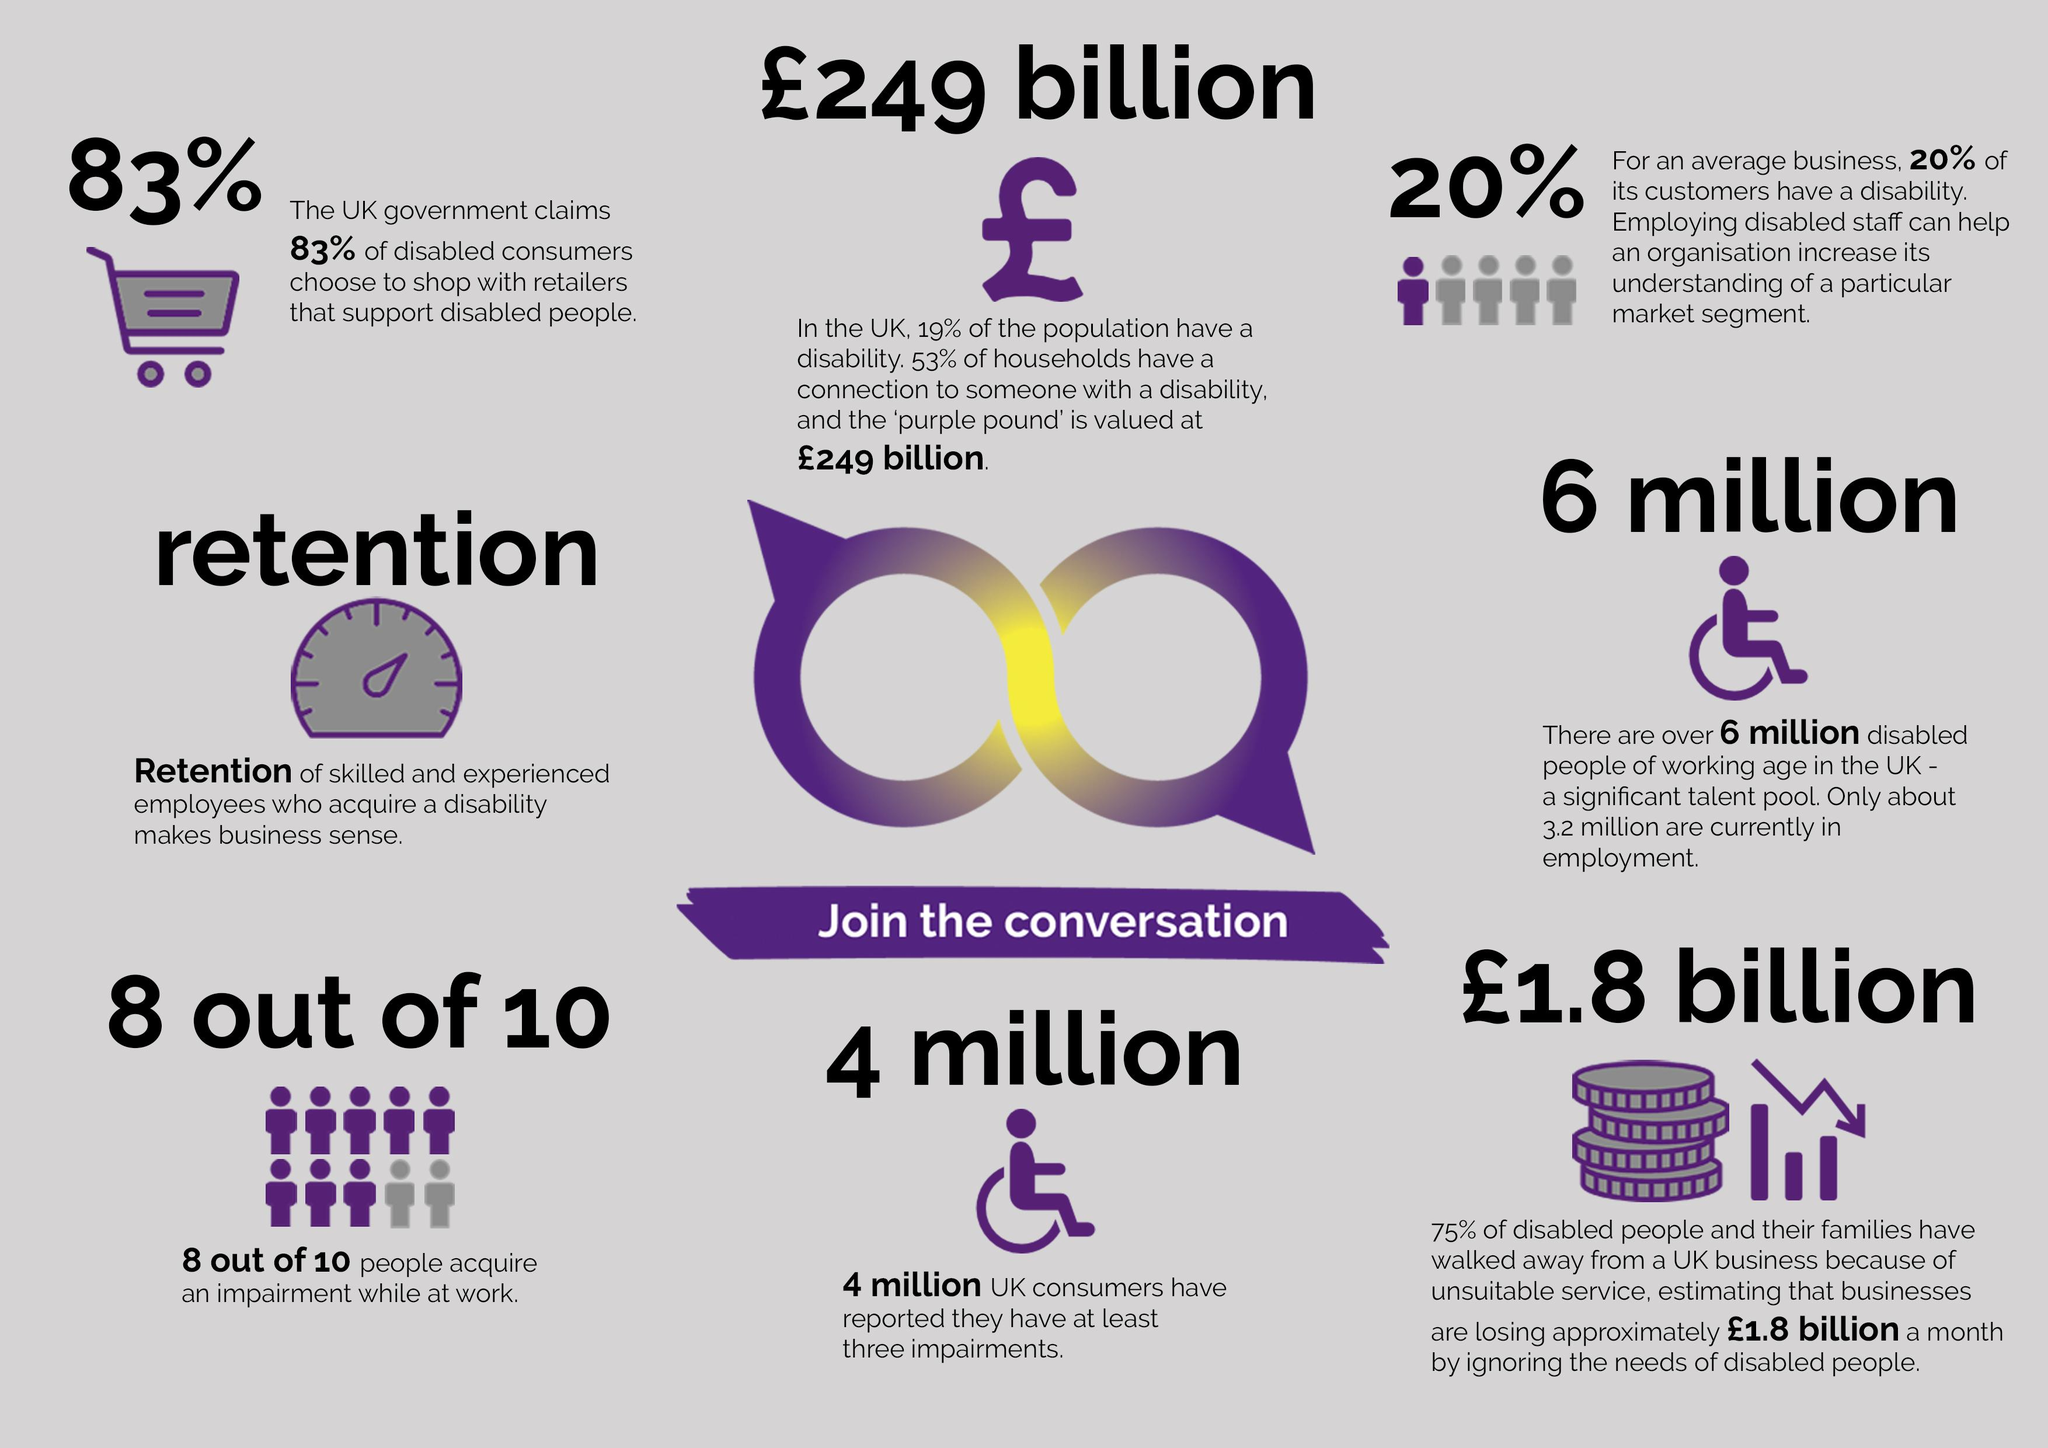Draw attention to some important aspects in this diagram. According to recent statistics, an estimated 2.4 million people with disabilities in the UK are unemployed. 